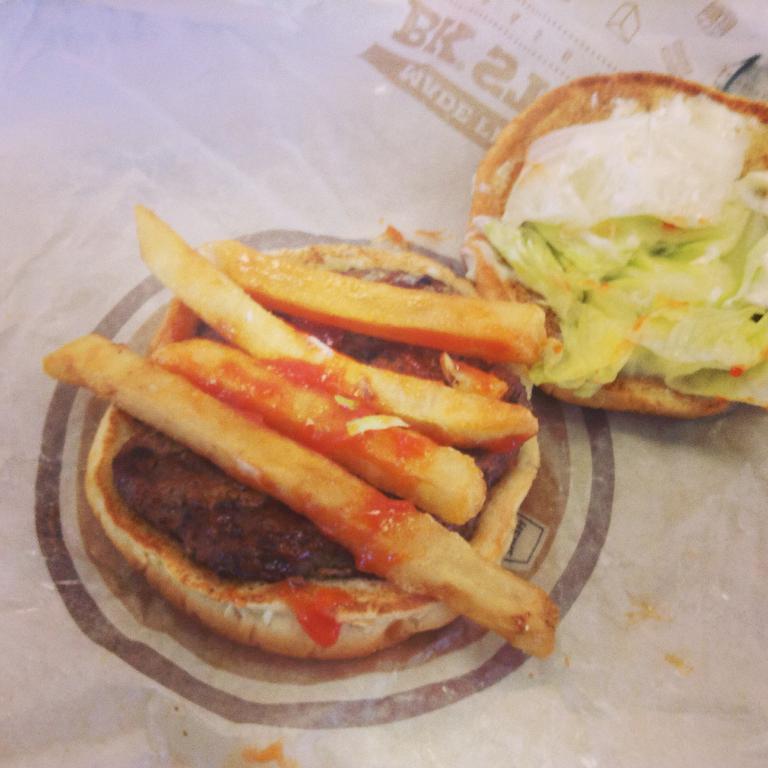Could you give a brief overview of what you see in this image? In this image in the center there is a burger and some french fries and sauce, and at the bottom there is a paper. 